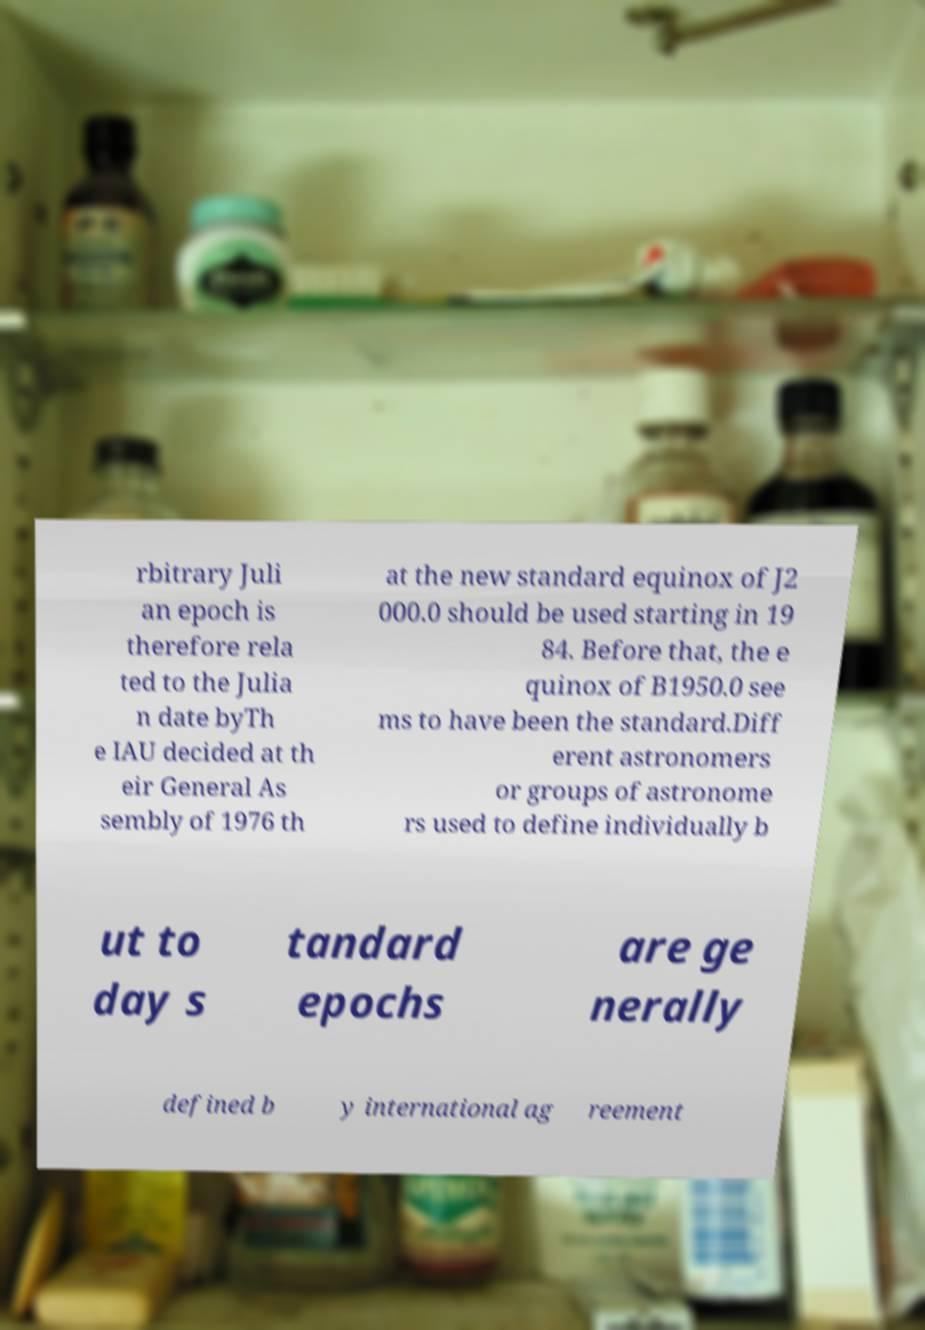Please identify and transcribe the text found in this image. rbitrary Juli an epoch is therefore rela ted to the Julia n date byTh e IAU decided at th eir General As sembly of 1976 th at the new standard equinox of J2 000.0 should be used starting in 19 84. Before that, the e quinox of B1950.0 see ms to have been the standard.Diff erent astronomers or groups of astronome rs used to define individually b ut to day s tandard epochs are ge nerally defined b y international ag reement 